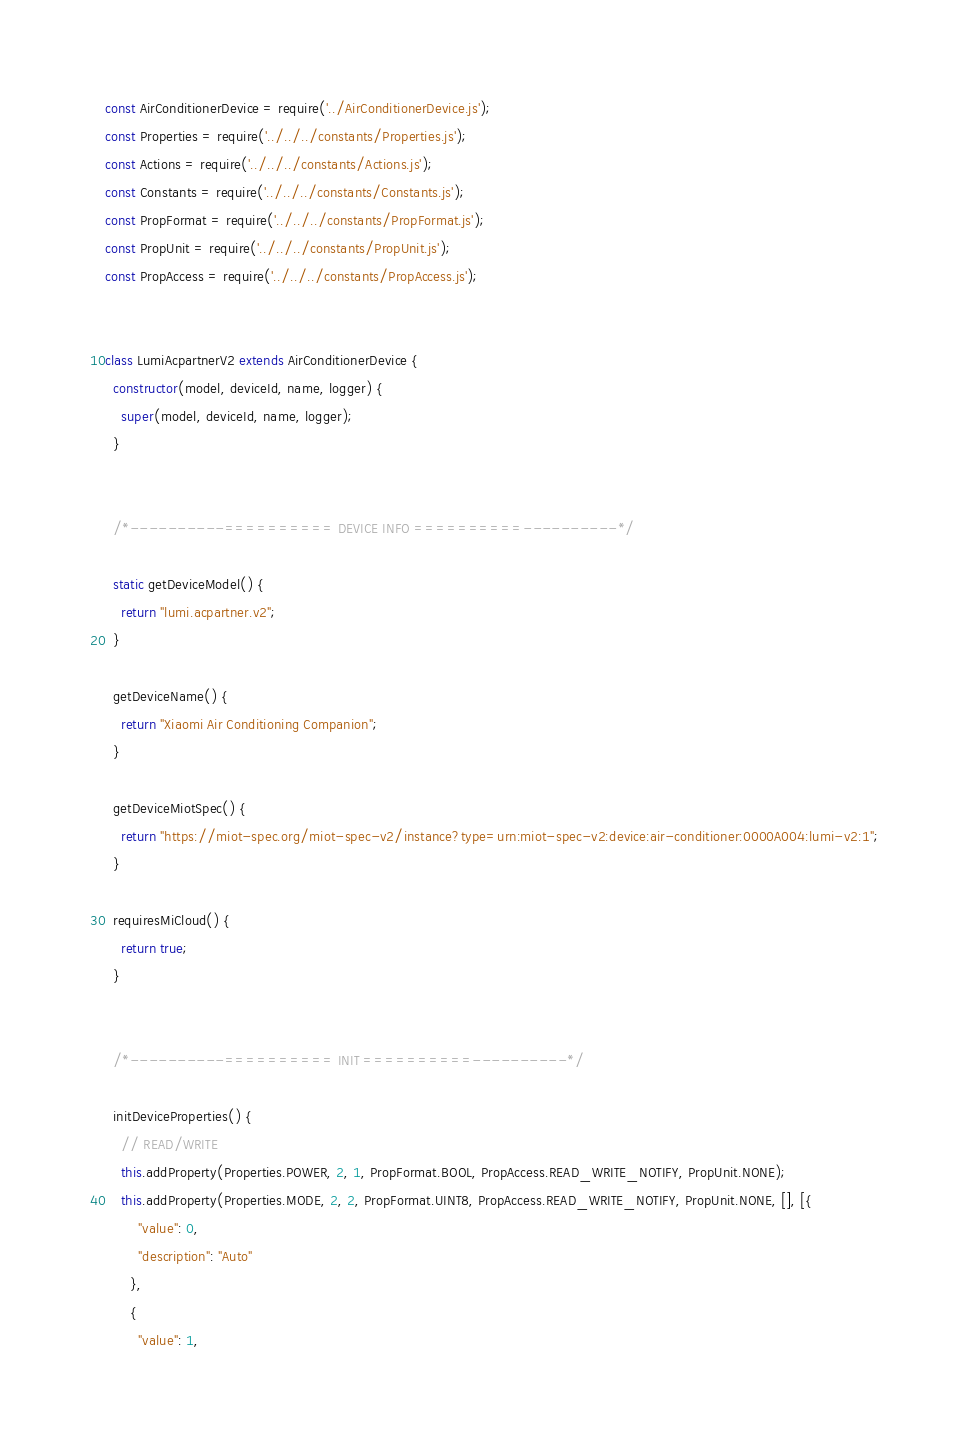<code> <loc_0><loc_0><loc_500><loc_500><_JavaScript_>const AirConditionerDevice = require('../AirConditionerDevice.js');
const Properties = require('../../../constants/Properties.js');
const Actions = require('../../../constants/Actions.js');
const Constants = require('../../../constants/Constants.js');
const PropFormat = require('../../../constants/PropFormat.js');
const PropUnit = require('../../../constants/PropUnit.js');
const PropAccess = require('../../../constants/PropAccess.js');


class LumiAcpartnerV2 extends AirConditionerDevice {
  constructor(model, deviceId, name, logger) {
    super(model, deviceId, name, logger);
  }


  /*----------========== DEVICE INFO ==========----------*/

  static getDeviceModel() {
    return "lumi.acpartner.v2";
  }

  getDeviceName() {
    return "Xiaomi Air Conditioning Companion";
  }

  getDeviceMiotSpec() {
    return "https://miot-spec.org/miot-spec-v2/instance?type=urn:miot-spec-v2:device:air-conditioner:0000A004:lumi-v2:1";
  }

  requiresMiCloud() {
    return true;
  }


  /*----------========== INIT ==========----------*/

  initDeviceProperties() {
    // READ/WRITE
    this.addProperty(Properties.POWER, 2, 1, PropFormat.BOOL, PropAccess.READ_WRITE_NOTIFY, PropUnit.NONE);
    this.addProperty(Properties.MODE, 2, 2, PropFormat.UINT8, PropAccess.READ_WRITE_NOTIFY, PropUnit.NONE, [], [{
        "value": 0,
        "description": "Auto"
      },
      {
        "value": 1,</code> 